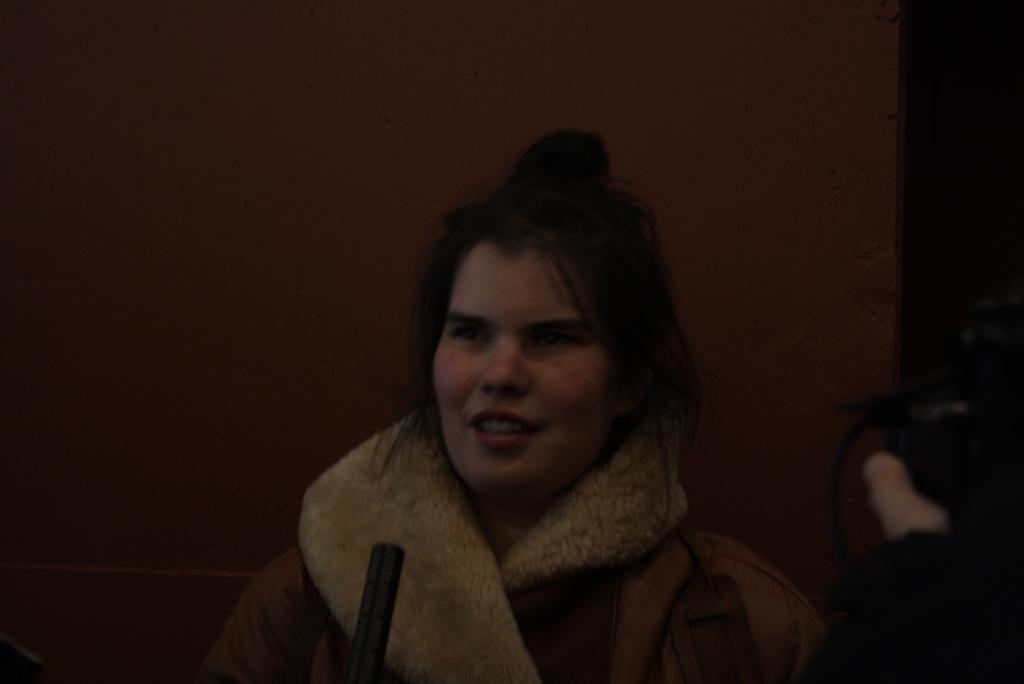Can you describe this image briefly? As we can see in the image there is a wall and a woman standing in the front. 